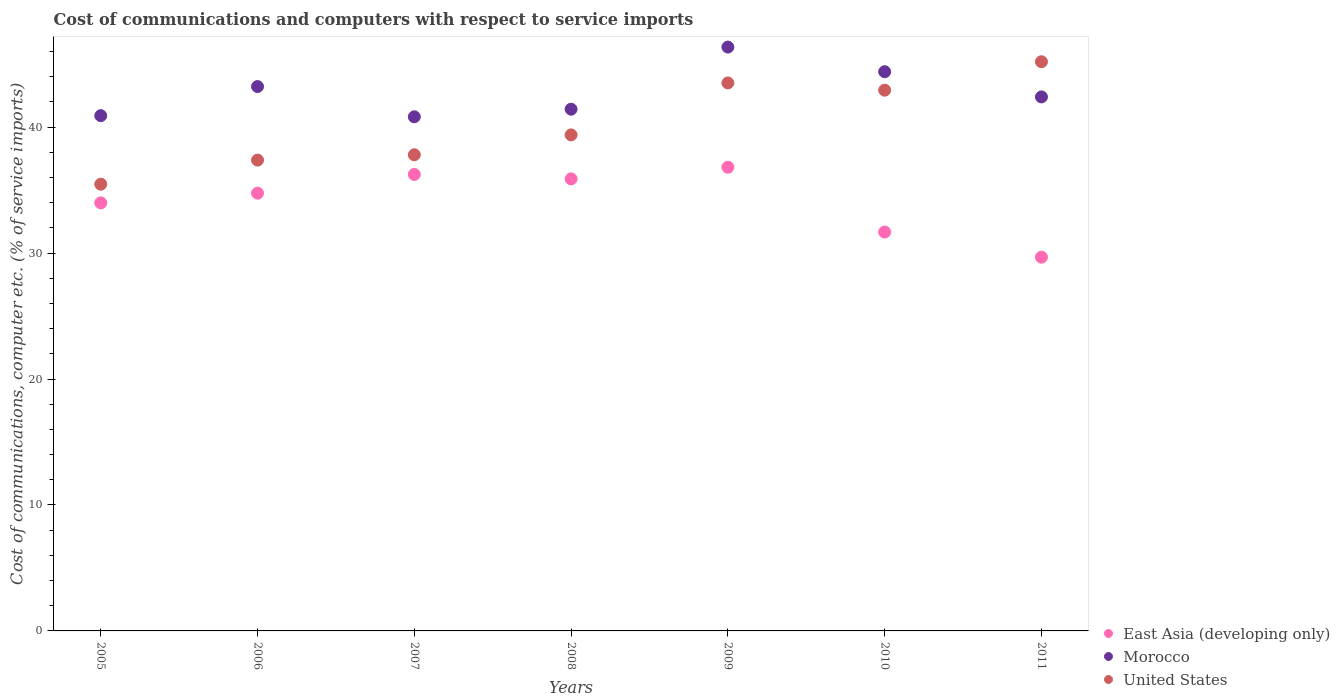Is the number of dotlines equal to the number of legend labels?
Provide a short and direct response. Yes. What is the cost of communications and computers in United States in 2010?
Offer a very short reply. 42.93. Across all years, what is the maximum cost of communications and computers in Morocco?
Offer a terse response. 46.36. Across all years, what is the minimum cost of communications and computers in Morocco?
Provide a succinct answer. 40.82. In which year was the cost of communications and computers in East Asia (developing only) maximum?
Keep it short and to the point. 2009. In which year was the cost of communications and computers in United States minimum?
Your response must be concise. 2005. What is the total cost of communications and computers in East Asia (developing only) in the graph?
Provide a succinct answer. 239.04. What is the difference between the cost of communications and computers in Morocco in 2006 and that in 2010?
Offer a very short reply. -1.18. What is the difference between the cost of communications and computers in East Asia (developing only) in 2011 and the cost of communications and computers in Morocco in 2008?
Your answer should be very brief. -11.75. What is the average cost of communications and computers in East Asia (developing only) per year?
Keep it short and to the point. 34.15. In the year 2011, what is the difference between the cost of communications and computers in Morocco and cost of communications and computers in United States?
Your answer should be compact. -2.79. In how many years, is the cost of communications and computers in United States greater than 16 %?
Ensure brevity in your answer.  7. What is the ratio of the cost of communications and computers in United States in 2010 to that in 2011?
Your response must be concise. 0.95. Is the cost of communications and computers in United States in 2007 less than that in 2008?
Ensure brevity in your answer.  Yes. Is the difference between the cost of communications and computers in Morocco in 2007 and 2011 greater than the difference between the cost of communications and computers in United States in 2007 and 2011?
Your answer should be very brief. Yes. What is the difference between the highest and the second highest cost of communications and computers in Morocco?
Provide a succinct answer. 1.95. What is the difference between the highest and the lowest cost of communications and computers in Morocco?
Your answer should be very brief. 5.54. Is the sum of the cost of communications and computers in United States in 2007 and 2009 greater than the maximum cost of communications and computers in East Asia (developing only) across all years?
Give a very brief answer. Yes. Is it the case that in every year, the sum of the cost of communications and computers in East Asia (developing only) and cost of communications and computers in United States  is greater than the cost of communications and computers in Morocco?
Keep it short and to the point. Yes. Does the cost of communications and computers in Morocco monotonically increase over the years?
Offer a very short reply. No. What is the difference between two consecutive major ticks on the Y-axis?
Your answer should be compact. 10. Are the values on the major ticks of Y-axis written in scientific E-notation?
Your answer should be compact. No. Does the graph contain any zero values?
Give a very brief answer. No. Where does the legend appear in the graph?
Your answer should be compact. Bottom right. How many legend labels are there?
Your response must be concise. 3. How are the legend labels stacked?
Provide a succinct answer. Vertical. What is the title of the graph?
Provide a succinct answer. Cost of communications and computers with respect to service imports. What is the label or title of the Y-axis?
Your answer should be very brief. Cost of communications, computer etc. (% of service imports). What is the Cost of communications, computer etc. (% of service imports) of East Asia (developing only) in 2005?
Give a very brief answer. 33.98. What is the Cost of communications, computer etc. (% of service imports) of Morocco in 2005?
Give a very brief answer. 40.91. What is the Cost of communications, computer etc. (% of service imports) in United States in 2005?
Offer a very short reply. 35.47. What is the Cost of communications, computer etc. (% of service imports) of East Asia (developing only) in 2006?
Your answer should be compact. 34.76. What is the Cost of communications, computer etc. (% of service imports) of Morocco in 2006?
Keep it short and to the point. 43.22. What is the Cost of communications, computer etc. (% of service imports) of United States in 2006?
Provide a short and direct response. 37.38. What is the Cost of communications, computer etc. (% of service imports) in East Asia (developing only) in 2007?
Give a very brief answer. 36.24. What is the Cost of communications, computer etc. (% of service imports) of Morocco in 2007?
Offer a very short reply. 40.82. What is the Cost of communications, computer etc. (% of service imports) in United States in 2007?
Offer a terse response. 37.8. What is the Cost of communications, computer etc. (% of service imports) in East Asia (developing only) in 2008?
Provide a short and direct response. 35.89. What is the Cost of communications, computer etc. (% of service imports) in Morocco in 2008?
Provide a succinct answer. 41.42. What is the Cost of communications, computer etc. (% of service imports) of United States in 2008?
Your answer should be compact. 39.38. What is the Cost of communications, computer etc. (% of service imports) in East Asia (developing only) in 2009?
Your answer should be very brief. 36.82. What is the Cost of communications, computer etc. (% of service imports) of Morocco in 2009?
Provide a succinct answer. 46.36. What is the Cost of communications, computer etc. (% of service imports) of United States in 2009?
Provide a short and direct response. 43.51. What is the Cost of communications, computer etc. (% of service imports) of East Asia (developing only) in 2010?
Your response must be concise. 31.67. What is the Cost of communications, computer etc. (% of service imports) of Morocco in 2010?
Give a very brief answer. 44.4. What is the Cost of communications, computer etc. (% of service imports) in United States in 2010?
Provide a succinct answer. 42.93. What is the Cost of communications, computer etc. (% of service imports) of East Asia (developing only) in 2011?
Offer a very short reply. 29.67. What is the Cost of communications, computer etc. (% of service imports) of Morocco in 2011?
Provide a short and direct response. 42.4. What is the Cost of communications, computer etc. (% of service imports) of United States in 2011?
Keep it short and to the point. 45.19. Across all years, what is the maximum Cost of communications, computer etc. (% of service imports) in East Asia (developing only)?
Offer a terse response. 36.82. Across all years, what is the maximum Cost of communications, computer etc. (% of service imports) in Morocco?
Your answer should be compact. 46.36. Across all years, what is the maximum Cost of communications, computer etc. (% of service imports) of United States?
Provide a succinct answer. 45.19. Across all years, what is the minimum Cost of communications, computer etc. (% of service imports) of East Asia (developing only)?
Your response must be concise. 29.67. Across all years, what is the minimum Cost of communications, computer etc. (% of service imports) of Morocco?
Provide a succinct answer. 40.82. Across all years, what is the minimum Cost of communications, computer etc. (% of service imports) of United States?
Your response must be concise. 35.47. What is the total Cost of communications, computer etc. (% of service imports) of East Asia (developing only) in the graph?
Keep it short and to the point. 239.04. What is the total Cost of communications, computer etc. (% of service imports) in Morocco in the graph?
Make the answer very short. 299.53. What is the total Cost of communications, computer etc. (% of service imports) of United States in the graph?
Your answer should be very brief. 281.67. What is the difference between the Cost of communications, computer etc. (% of service imports) of East Asia (developing only) in 2005 and that in 2006?
Your answer should be very brief. -0.77. What is the difference between the Cost of communications, computer etc. (% of service imports) in Morocco in 2005 and that in 2006?
Make the answer very short. -2.31. What is the difference between the Cost of communications, computer etc. (% of service imports) in United States in 2005 and that in 2006?
Your answer should be compact. -1.91. What is the difference between the Cost of communications, computer etc. (% of service imports) in East Asia (developing only) in 2005 and that in 2007?
Provide a succinct answer. -2.26. What is the difference between the Cost of communications, computer etc. (% of service imports) in Morocco in 2005 and that in 2007?
Provide a succinct answer. 0.09. What is the difference between the Cost of communications, computer etc. (% of service imports) of United States in 2005 and that in 2007?
Provide a succinct answer. -2.34. What is the difference between the Cost of communications, computer etc. (% of service imports) of East Asia (developing only) in 2005 and that in 2008?
Your answer should be compact. -1.91. What is the difference between the Cost of communications, computer etc. (% of service imports) of Morocco in 2005 and that in 2008?
Ensure brevity in your answer.  -0.51. What is the difference between the Cost of communications, computer etc. (% of service imports) in United States in 2005 and that in 2008?
Offer a very short reply. -3.92. What is the difference between the Cost of communications, computer etc. (% of service imports) of East Asia (developing only) in 2005 and that in 2009?
Make the answer very short. -2.83. What is the difference between the Cost of communications, computer etc. (% of service imports) in Morocco in 2005 and that in 2009?
Keep it short and to the point. -5.44. What is the difference between the Cost of communications, computer etc. (% of service imports) in United States in 2005 and that in 2009?
Provide a short and direct response. -8.04. What is the difference between the Cost of communications, computer etc. (% of service imports) in East Asia (developing only) in 2005 and that in 2010?
Your answer should be very brief. 2.32. What is the difference between the Cost of communications, computer etc. (% of service imports) in Morocco in 2005 and that in 2010?
Offer a very short reply. -3.49. What is the difference between the Cost of communications, computer etc. (% of service imports) of United States in 2005 and that in 2010?
Offer a terse response. -7.47. What is the difference between the Cost of communications, computer etc. (% of service imports) of East Asia (developing only) in 2005 and that in 2011?
Offer a terse response. 4.31. What is the difference between the Cost of communications, computer etc. (% of service imports) in Morocco in 2005 and that in 2011?
Provide a short and direct response. -1.49. What is the difference between the Cost of communications, computer etc. (% of service imports) in United States in 2005 and that in 2011?
Your answer should be very brief. -9.72. What is the difference between the Cost of communications, computer etc. (% of service imports) of East Asia (developing only) in 2006 and that in 2007?
Offer a very short reply. -1.49. What is the difference between the Cost of communications, computer etc. (% of service imports) in Morocco in 2006 and that in 2007?
Offer a terse response. 2.4. What is the difference between the Cost of communications, computer etc. (% of service imports) in United States in 2006 and that in 2007?
Offer a terse response. -0.42. What is the difference between the Cost of communications, computer etc. (% of service imports) in East Asia (developing only) in 2006 and that in 2008?
Your response must be concise. -1.14. What is the difference between the Cost of communications, computer etc. (% of service imports) in Morocco in 2006 and that in 2008?
Your answer should be very brief. 1.8. What is the difference between the Cost of communications, computer etc. (% of service imports) in United States in 2006 and that in 2008?
Keep it short and to the point. -2. What is the difference between the Cost of communications, computer etc. (% of service imports) of East Asia (developing only) in 2006 and that in 2009?
Your answer should be compact. -2.06. What is the difference between the Cost of communications, computer etc. (% of service imports) in Morocco in 2006 and that in 2009?
Keep it short and to the point. -3.14. What is the difference between the Cost of communications, computer etc. (% of service imports) of United States in 2006 and that in 2009?
Ensure brevity in your answer.  -6.13. What is the difference between the Cost of communications, computer etc. (% of service imports) of East Asia (developing only) in 2006 and that in 2010?
Your answer should be compact. 3.09. What is the difference between the Cost of communications, computer etc. (% of service imports) in Morocco in 2006 and that in 2010?
Offer a very short reply. -1.18. What is the difference between the Cost of communications, computer etc. (% of service imports) in United States in 2006 and that in 2010?
Make the answer very short. -5.55. What is the difference between the Cost of communications, computer etc. (% of service imports) in East Asia (developing only) in 2006 and that in 2011?
Make the answer very short. 5.08. What is the difference between the Cost of communications, computer etc. (% of service imports) in Morocco in 2006 and that in 2011?
Provide a short and direct response. 0.82. What is the difference between the Cost of communications, computer etc. (% of service imports) of United States in 2006 and that in 2011?
Offer a very short reply. -7.81. What is the difference between the Cost of communications, computer etc. (% of service imports) of East Asia (developing only) in 2007 and that in 2008?
Your answer should be compact. 0.35. What is the difference between the Cost of communications, computer etc. (% of service imports) of Morocco in 2007 and that in 2008?
Offer a terse response. -0.6. What is the difference between the Cost of communications, computer etc. (% of service imports) in United States in 2007 and that in 2008?
Make the answer very short. -1.58. What is the difference between the Cost of communications, computer etc. (% of service imports) of East Asia (developing only) in 2007 and that in 2009?
Your response must be concise. -0.57. What is the difference between the Cost of communications, computer etc. (% of service imports) in Morocco in 2007 and that in 2009?
Keep it short and to the point. -5.54. What is the difference between the Cost of communications, computer etc. (% of service imports) in United States in 2007 and that in 2009?
Your answer should be compact. -5.7. What is the difference between the Cost of communications, computer etc. (% of service imports) in East Asia (developing only) in 2007 and that in 2010?
Ensure brevity in your answer.  4.58. What is the difference between the Cost of communications, computer etc. (% of service imports) in Morocco in 2007 and that in 2010?
Your response must be concise. -3.58. What is the difference between the Cost of communications, computer etc. (% of service imports) in United States in 2007 and that in 2010?
Provide a short and direct response. -5.13. What is the difference between the Cost of communications, computer etc. (% of service imports) of East Asia (developing only) in 2007 and that in 2011?
Give a very brief answer. 6.57. What is the difference between the Cost of communications, computer etc. (% of service imports) in Morocco in 2007 and that in 2011?
Provide a succinct answer. -1.58. What is the difference between the Cost of communications, computer etc. (% of service imports) in United States in 2007 and that in 2011?
Offer a very short reply. -7.39. What is the difference between the Cost of communications, computer etc. (% of service imports) in East Asia (developing only) in 2008 and that in 2009?
Give a very brief answer. -0.93. What is the difference between the Cost of communications, computer etc. (% of service imports) of Morocco in 2008 and that in 2009?
Your answer should be compact. -4.93. What is the difference between the Cost of communications, computer etc. (% of service imports) of United States in 2008 and that in 2009?
Give a very brief answer. -4.12. What is the difference between the Cost of communications, computer etc. (% of service imports) in East Asia (developing only) in 2008 and that in 2010?
Provide a succinct answer. 4.22. What is the difference between the Cost of communications, computer etc. (% of service imports) of Morocco in 2008 and that in 2010?
Offer a terse response. -2.98. What is the difference between the Cost of communications, computer etc. (% of service imports) of United States in 2008 and that in 2010?
Your response must be concise. -3.55. What is the difference between the Cost of communications, computer etc. (% of service imports) of East Asia (developing only) in 2008 and that in 2011?
Ensure brevity in your answer.  6.22. What is the difference between the Cost of communications, computer etc. (% of service imports) in Morocco in 2008 and that in 2011?
Your answer should be very brief. -0.98. What is the difference between the Cost of communications, computer etc. (% of service imports) in United States in 2008 and that in 2011?
Offer a very short reply. -5.81. What is the difference between the Cost of communications, computer etc. (% of service imports) in East Asia (developing only) in 2009 and that in 2010?
Make the answer very short. 5.15. What is the difference between the Cost of communications, computer etc. (% of service imports) in Morocco in 2009 and that in 2010?
Your answer should be compact. 1.95. What is the difference between the Cost of communications, computer etc. (% of service imports) in United States in 2009 and that in 2010?
Give a very brief answer. 0.57. What is the difference between the Cost of communications, computer etc. (% of service imports) of East Asia (developing only) in 2009 and that in 2011?
Give a very brief answer. 7.14. What is the difference between the Cost of communications, computer etc. (% of service imports) in Morocco in 2009 and that in 2011?
Offer a very short reply. 3.96. What is the difference between the Cost of communications, computer etc. (% of service imports) in United States in 2009 and that in 2011?
Offer a terse response. -1.68. What is the difference between the Cost of communications, computer etc. (% of service imports) in East Asia (developing only) in 2010 and that in 2011?
Keep it short and to the point. 1.99. What is the difference between the Cost of communications, computer etc. (% of service imports) in Morocco in 2010 and that in 2011?
Make the answer very short. 2. What is the difference between the Cost of communications, computer etc. (% of service imports) in United States in 2010 and that in 2011?
Offer a very short reply. -2.26. What is the difference between the Cost of communications, computer etc. (% of service imports) of East Asia (developing only) in 2005 and the Cost of communications, computer etc. (% of service imports) of Morocco in 2006?
Make the answer very short. -9.24. What is the difference between the Cost of communications, computer etc. (% of service imports) of East Asia (developing only) in 2005 and the Cost of communications, computer etc. (% of service imports) of United States in 2006?
Ensure brevity in your answer.  -3.4. What is the difference between the Cost of communications, computer etc. (% of service imports) in Morocco in 2005 and the Cost of communications, computer etc. (% of service imports) in United States in 2006?
Make the answer very short. 3.53. What is the difference between the Cost of communications, computer etc. (% of service imports) in East Asia (developing only) in 2005 and the Cost of communications, computer etc. (% of service imports) in Morocco in 2007?
Provide a short and direct response. -6.84. What is the difference between the Cost of communications, computer etc. (% of service imports) of East Asia (developing only) in 2005 and the Cost of communications, computer etc. (% of service imports) of United States in 2007?
Offer a very short reply. -3.82. What is the difference between the Cost of communications, computer etc. (% of service imports) of Morocco in 2005 and the Cost of communications, computer etc. (% of service imports) of United States in 2007?
Keep it short and to the point. 3.11. What is the difference between the Cost of communications, computer etc. (% of service imports) of East Asia (developing only) in 2005 and the Cost of communications, computer etc. (% of service imports) of Morocco in 2008?
Keep it short and to the point. -7.44. What is the difference between the Cost of communications, computer etc. (% of service imports) in East Asia (developing only) in 2005 and the Cost of communications, computer etc. (% of service imports) in United States in 2008?
Offer a very short reply. -5.4. What is the difference between the Cost of communications, computer etc. (% of service imports) in Morocco in 2005 and the Cost of communications, computer etc. (% of service imports) in United States in 2008?
Provide a short and direct response. 1.53. What is the difference between the Cost of communications, computer etc. (% of service imports) of East Asia (developing only) in 2005 and the Cost of communications, computer etc. (% of service imports) of Morocco in 2009?
Give a very brief answer. -12.37. What is the difference between the Cost of communications, computer etc. (% of service imports) in East Asia (developing only) in 2005 and the Cost of communications, computer etc. (% of service imports) in United States in 2009?
Your answer should be very brief. -9.52. What is the difference between the Cost of communications, computer etc. (% of service imports) in Morocco in 2005 and the Cost of communications, computer etc. (% of service imports) in United States in 2009?
Your response must be concise. -2.6. What is the difference between the Cost of communications, computer etc. (% of service imports) in East Asia (developing only) in 2005 and the Cost of communications, computer etc. (% of service imports) in Morocco in 2010?
Keep it short and to the point. -10.42. What is the difference between the Cost of communications, computer etc. (% of service imports) of East Asia (developing only) in 2005 and the Cost of communications, computer etc. (% of service imports) of United States in 2010?
Give a very brief answer. -8.95. What is the difference between the Cost of communications, computer etc. (% of service imports) of Morocco in 2005 and the Cost of communications, computer etc. (% of service imports) of United States in 2010?
Your answer should be very brief. -2.02. What is the difference between the Cost of communications, computer etc. (% of service imports) in East Asia (developing only) in 2005 and the Cost of communications, computer etc. (% of service imports) in Morocco in 2011?
Make the answer very short. -8.42. What is the difference between the Cost of communications, computer etc. (% of service imports) of East Asia (developing only) in 2005 and the Cost of communications, computer etc. (% of service imports) of United States in 2011?
Offer a terse response. -11.21. What is the difference between the Cost of communications, computer etc. (% of service imports) in Morocco in 2005 and the Cost of communications, computer etc. (% of service imports) in United States in 2011?
Your answer should be compact. -4.28. What is the difference between the Cost of communications, computer etc. (% of service imports) of East Asia (developing only) in 2006 and the Cost of communications, computer etc. (% of service imports) of Morocco in 2007?
Ensure brevity in your answer.  -6.06. What is the difference between the Cost of communications, computer etc. (% of service imports) in East Asia (developing only) in 2006 and the Cost of communications, computer etc. (% of service imports) in United States in 2007?
Ensure brevity in your answer.  -3.05. What is the difference between the Cost of communications, computer etc. (% of service imports) in Morocco in 2006 and the Cost of communications, computer etc. (% of service imports) in United States in 2007?
Your answer should be compact. 5.42. What is the difference between the Cost of communications, computer etc. (% of service imports) of East Asia (developing only) in 2006 and the Cost of communications, computer etc. (% of service imports) of Morocco in 2008?
Your response must be concise. -6.67. What is the difference between the Cost of communications, computer etc. (% of service imports) of East Asia (developing only) in 2006 and the Cost of communications, computer etc. (% of service imports) of United States in 2008?
Provide a short and direct response. -4.63. What is the difference between the Cost of communications, computer etc. (% of service imports) in Morocco in 2006 and the Cost of communications, computer etc. (% of service imports) in United States in 2008?
Keep it short and to the point. 3.84. What is the difference between the Cost of communications, computer etc. (% of service imports) in East Asia (developing only) in 2006 and the Cost of communications, computer etc. (% of service imports) in Morocco in 2009?
Offer a very short reply. -11.6. What is the difference between the Cost of communications, computer etc. (% of service imports) of East Asia (developing only) in 2006 and the Cost of communications, computer etc. (% of service imports) of United States in 2009?
Make the answer very short. -8.75. What is the difference between the Cost of communications, computer etc. (% of service imports) of Morocco in 2006 and the Cost of communications, computer etc. (% of service imports) of United States in 2009?
Offer a very short reply. -0.29. What is the difference between the Cost of communications, computer etc. (% of service imports) of East Asia (developing only) in 2006 and the Cost of communications, computer etc. (% of service imports) of Morocco in 2010?
Your answer should be compact. -9.65. What is the difference between the Cost of communications, computer etc. (% of service imports) in East Asia (developing only) in 2006 and the Cost of communications, computer etc. (% of service imports) in United States in 2010?
Provide a short and direct response. -8.18. What is the difference between the Cost of communications, computer etc. (% of service imports) of Morocco in 2006 and the Cost of communications, computer etc. (% of service imports) of United States in 2010?
Your answer should be very brief. 0.29. What is the difference between the Cost of communications, computer etc. (% of service imports) of East Asia (developing only) in 2006 and the Cost of communications, computer etc. (% of service imports) of Morocco in 2011?
Your response must be concise. -7.65. What is the difference between the Cost of communications, computer etc. (% of service imports) in East Asia (developing only) in 2006 and the Cost of communications, computer etc. (% of service imports) in United States in 2011?
Offer a very short reply. -10.44. What is the difference between the Cost of communications, computer etc. (% of service imports) of Morocco in 2006 and the Cost of communications, computer etc. (% of service imports) of United States in 2011?
Your answer should be very brief. -1.97. What is the difference between the Cost of communications, computer etc. (% of service imports) in East Asia (developing only) in 2007 and the Cost of communications, computer etc. (% of service imports) in Morocco in 2008?
Your answer should be very brief. -5.18. What is the difference between the Cost of communications, computer etc. (% of service imports) in East Asia (developing only) in 2007 and the Cost of communications, computer etc. (% of service imports) in United States in 2008?
Your answer should be compact. -3.14. What is the difference between the Cost of communications, computer etc. (% of service imports) in Morocco in 2007 and the Cost of communications, computer etc. (% of service imports) in United States in 2008?
Offer a terse response. 1.44. What is the difference between the Cost of communications, computer etc. (% of service imports) of East Asia (developing only) in 2007 and the Cost of communications, computer etc. (% of service imports) of Morocco in 2009?
Give a very brief answer. -10.11. What is the difference between the Cost of communications, computer etc. (% of service imports) of East Asia (developing only) in 2007 and the Cost of communications, computer etc. (% of service imports) of United States in 2009?
Your answer should be very brief. -7.26. What is the difference between the Cost of communications, computer etc. (% of service imports) in Morocco in 2007 and the Cost of communications, computer etc. (% of service imports) in United States in 2009?
Provide a succinct answer. -2.69. What is the difference between the Cost of communications, computer etc. (% of service imports) in East Asia (developing only) in 2007 and the Cost of communications, computer etc. (% of service imports) in Morocco in 2010?
Provide a short and direct response. -8.16. What is the difference between the Cost of communications, computer etc. (% of service imports) of East Asia (developing only) in 2007 and the Cost of communications, computer etc. (% of service imports) of United States in 2010?
Provide a succinct answer. -6.69. What is the difference between the Cost of communications, computer etc. (% of service imports) in Morocco in 2007 and the Cost of communications, computer etc. (% of service imports) in United States in 2010?
Make the answer very short. -2.11. What is the difference between the Cost of communications, computer etc. (% of service imports) in East Asia (developing only) in 2007 and the Cost of communications, computer etc. (% of service imports) in Morocco in 2011?
Give a very brief answer. -6.16. What is the difference between the Cost of communications, computer etc. (% of service imports) of East Asia (developing only) in 2007 and the Cost of communications, computer etc. (% of service imports) of United States in 2011?
Your answer should be very brief. -8.95. What is the difference between the Cost of communications, computer etc. (% of service imports) in Morocco in 2007 and the Cost of communications, computer etc. (% of service imports) in United States in 2011?
Keep it short and to the point. -4.37. What is the difference between the Cost of communications, computer etc. (% of service imports) of East Asia (developing only) in 2008 and the Cost of communications, computer etc. (% of service imports) of Morocco in 2009?
Make the answer very short. -10.47. What is the difference between the Cost of communications, computer etc. (% of service imports) of East Asia (developing only) in 2008 and the Cost of communications, computer etc. (% of service imports) of United States in 2009?
Offer a terse response. -7.62. What is the difference between the Cost of communications, computer etc. (% of service imports) of Morocco in 2008 and the Cost of communications, computer etc. (% of service imports) of United States in 2009?
Provide a short and direct response. -2.08. What is the difference between the Cost of communications, computer etc. (% of service imports) of East Asia (developing only) in 2008 and the Cost of communications, computer etc. (% of service imports) of Morocco in 2010?
Make the answer very short. -8.51. What is the difference between the Cost of communications, computer etc. (% of service imports) of East Asia (developing only) in 2008 and the Cost of communications, computer etc. (% of service imports) of United States in 2010?
Give a very brief answer. -7.04. What is the difference between the Cost of communications, computer etc. (% of service imports) of Morocco in 2008 and the Cost of communications, computer etc. (% of service imports) of United States in 2010?
Your answer should be compact. -1.51. What is the difference between the Cost of communications, computer etc. (% of service imports) in East Asia (developing only) in 2008 and the Cost of communications, computer etc. (% of service imports) in Morocco in 2011?
Offer a very short reply. -6.51. What is the difference between the Cost of communications, computer etc. (% of service imports) in East Asia (developing only) in 2008 and the Cost of communications, computer etc. (% of service imports) in United States in 2011?
Offer a terse response. -9.3. What is the difference between the Cost of communications, computer etc. (% of service imports) of Morocco in 2008 and the Cost of communications, computer etc. (% of service imports) of United States in 2011?
Give a very brief answer. -3.77. What is the difference between the Cost of communications, computer etc. (% of service imports) of East Asia (developing only) in 2009 and the Cost of communications, computer etc. (% of service imports) of Morocco in 2010?
Offer a very short reply. -7.58. What is the difference between the Cost of communications, computer etc. (% of service imports) in East Asia (developing only) in 2009 and the Cost of communications, computer etc. (% of service imports) in United States in 2010?
Make the answer very short. -6.12. What is the difference between the Cost of communications, computer etc. (% of service imports) of Morocco in 2009 and the Cost of communications, computer etc. (% of service imports) of United States in 2010?
Provide a succinct answer. 3.42. What is the difference between the Cost of communications, computer etc. (% of service imports) in East Asia (developing only) in 2009 and the Cost of communications, computer etc. (% of service imports) in Morocco in 2011?
Ensure brevity in your answer.  -5.58. What is the difference between the Cost of communications, computer etc. (% of service imports) in East Asia (developing only) in 2009 and the Cost of communications, computer etc. (% of service imports) in United States in 2011?
Offer a terse response. -8.37. What is the difference between the Cost of communications, computer etc. (% of service imports) in Morocco in 2009 and the Cost of communications, computer etc. (% of service imports) in United States in 2011?
Provide a succinct answer. 1.16. What is the difference between the Cost of communications, computer etc. (% of service imports) in East Asia (developing only) in 2010 and the Cost of communications, computer etc. (% of service imports) in Morocco in 2011?
Keep it short and to the point. -10.73. What is the difference between the Cost of communications, computer etc. (% of service imports) of East Asia (developing only) in 2010 and the Cost of communications, computer etc. (% of service imports) of United States in 2011?
Make the answer very short. -13.52. What is the difference between the Cost of communications, computer etc. (% of service imports) in Morocco in 2010 and the Cost of communications, computer etc. (% of service imports) in United States in 2011?
Your answer should be compact. -0.79. What is the average Cost of communications, computer etc. (% of service imports) in East Asia (developing only) per year?
Your answer should be very brief. 34.15. What is the average Cost of communications, computer etc. (% of service imports) of Morocco per year?
Keep it short and to the point. 42.79. What is the average Cost of communications, computer etc. (% of service imports) in United States per year?
Make the answer very short. 40.24. In the year 2005, what is the difference between the Cost of communications, computer etc. (% of service imports) of East Asia (developing only) and Cost of communications, computer etc. (% of service imports) of Morocco?
Provide a short and direct response. -6.93. In the year 2005, what is the difference between the Cost of communications, computer etc. (% of service imports) in East Asia (developing only) and Cost of communications, computer etc. (% of service imports) in United States?
Your response must be concise. -1.48. In the year 2005, what is the difference between the Cost of communications, computer etc. (% of service imports) of Morocco and Cost of communications, computer etc. (% of service imports) of United States?
Make the answer very short. 5.44. In the year 2006, what is the difference between the Cost of communications, computer etc. (% of service imports) of East Asia (developing only) and Cost of communications, computer etc. (% of service imports) of Morocco?
Make the answer very short. -8.47. In the year 2006, what is the difference between the Cost of communications, computer etc. (% of service imports) in East Asia (developing only) and Cost of communications, computer etc. (% of service imports) in United States?
Offer a very short reply. -2.63. In the year 2006, what is the difference between the Cost of communications, computer etc. (% of service imports) of Morocco and Cost of communications, computer etc. (% of service imports) of United States?
Your answer should be compact. 5.84. In the year 2007, what is the difference between the Cost of communications, computer etc. (% of service imports) in East Asia (developing only) and Cost of communications, computer etc. (% of service imports) in Morocco?
Your answer should be compact. -4.57. In the year 2007, what is the difference between the Cost of communications, computer etc. (% of service imports) in East Asia (developing only) and Cost of communications, computer etc. (% of service imports) in United States?
Your response must be concise. -1.56. In the year 2007, what is the difference between the Cost of communications, computer etc. (% of service imports) in Morocco and Cost of communications, computer etc. (% of service imports) in United States?
Offer a very short reply. 3.02. In the year 2008, what is the difference between the Cost of communications, computer etc. (% of service imports) of East Asia (developing only) and Cost of communications, computer etc. (% of service imports) of Morocco?
Give a very brief answer. -5.53. In the year 2008, what is the difference between the Cost of communications, computer etc. (% of service imports) of East Asia (developing only) and Cost of communications, computer etc. (% of service imports) of United States?
Your answer should be very brief. -3.49. In the year 2008, what is the difference between the Cost of communications, computer etc. (% of service imports) of Morocco and Cost of communications, computer etc. (% of service imports) of United States?
Your response must be concise. 2.04. In the year 2009, what is the difference between the Cost of communications, computer etc. (% of service imports) in East Asia (developing only) and Cost of communications, computer etc. (% of service imports) in Morocco?
Offer a terse response. -9.54. In the year 2009, what is the difference between the Cost of communications, computer etc. (% of service imports) in East Asia (developing only) and Cost of communications, computer etc. (% of service imports) in United States?
Provide a short and direct response. -6.69. In the year 2009, what is the difference between the Cost of communications, computer etc. (% of service imports) of Morocco and Cost of communications, computer etc. (% of service imports) of United States?
Keep it short and to the point. 2.85. In the year 2010, what is the difference between the Cost of communications, computer etc. (% of service imports) of East Asia (developing only) and Cost of communications, computer etc. (% of service imports) of Morocco?
Keep it short and to the point. -12.73. In the year 2010, what is the difference between the Cost of communications, computer etc. (% of service imports) of East Asia (developing only) and Cost of communications, computer etc. (% of service imports) of United States?
Offer a terse response. -11.26. In the year 2010, what is the difference between the Cost of communications, computer etc. (% of service imports) of Morocco and Cost of communications, computer etc. (% of service imports) of United States?
Offer a very short reply. 1.47. In the year 2011, what is the difference between the Cost of communications, computer etc. (% of service imports) of East Asia (developing only) and Cost of communications, computer etc. (% of service imports) of Morocco?
Your answer should be very brief. -12.73. In the year 2011, what is the difference between the Cost of communications, computer etc. (% of service imports) of East Asia (developing only) and Cost of communications, computer etc. (% of service imports) of United States?
Your response must be concise. -15.52. In the year 2011, what is the difference between the Cost of communications, computer etc. (% of service imports) of Morocco and Cost of communications, computer etc. (% of service imports) of United States?
Offer a terse response. -2.79. What is the ratio of the Cost of communications, computer etc. (% of service imports) in East Asia (developing only) in 2005 to that in 2006?
Make the answer very short. 0.98. What is the ratio of the Cost of communications, computer etc. (% of service imports) in Morocco in 2005 to that in 2006?
Give a very brief answer. 0.95. What is the ratio of the Cost of communications, computer etc. (% of service imports) of United States in 2005 to that in 2006?
Give a very brief answer. 0.95. What is the ratio of the Cost of communications, computer etc. (% of service imports) of East Asia (developing only) in 2005 to that in 2007?
Your answer should be very brief. 0.94. What is the ratio of the Cost of communications, computer etc. (% of service imports) in Morocco in 2005 to that in 2007?
Make the answer very short. 1. What is the ratio of the Cost of communications, computer etc. (% of service imports) of United States in 2005 to that in 2007?
Keep it short and to the point. 0.94. What is the ratio of the Cost of communications, computer etc. (% of service imports) of East Asia (developing only) in 2005 to that in 2008?
Provide a short and direct response. 0.95. What is the ratio of the Cost of communications, computer etc. (% of service imports) of Morocco in 2005 to that in 2008?
Offer a very short reply. 0.99. What is the ratio of the Cost of communications, computer etc. (% of service imports) of United States in 2005 to that in 2008?
Your response must be concise. 0.9. What is the ratio of the Cost of communications, computer etc. (% of service imports) of East Asia (developing only) in 2005 to that in 2009?
Your answer should be compact. 0.92. What is the ratio of the Cost of communications, computer etc. (% of service imports) in Morocco in 2005 to that in 2009?
Your response must be concise. 0.88. What is the ratio of the Cost of communications, computer etc. (% of service imports) of United States in 2005 to that in 2009?
Your response must be concise. 0.82. What is the ratio of the Cost of communications, computer etc. (% of service imports) of East Asia (developing only) in 2005 to that in 2010?
Offer a very short reply. 1.07. What is the ratio of the Cost of communications, computer etc. (% of service imports) of Morocco in 2005 to that in 2010?
Your answer should be very brief. 0.92. What is the ratio of the Cost of communications, computer etc. (% of service imports) of United States in 2005 to that in 2010?
Offer a terse response. 0.83. What is the ratio of the Cost of communications, computer etc. (% of service imports) of East Asia (developing only) in 2005 to that in 2011?
Your response must be concise. 1.15. What is the ratio of the Cost of communications, computer etc. (% of service imports) in Morocco in 2005 to that in 2011?
Your answer should be very brief. 0.96. What is the ratio of the Cost of communications, computer etc. (% of service imports) in United States in 2005 to that in 2011?
Provide a short and direct response. 0.78. What is the ratio of the Cost of communications, computer etc. (% of service imports) in East Asia (developing only) in 2006 to that in 2007?
Offer a terse response. 0.96. What is the ratio of the Cost of communications, computer etc. (% of service imports) in Morocco in 2006 to that in 2007?
Offer a very short reply. 1.06. What is the ratio of the Cost of communications, computer etc. (% of service imports) of East Asia (developing only) in 2006 to that in 2008?
Your answer should be compact. 0.97. What is the ratio of the Cost of communications, computer etc. (% of service imports) in Morocco in 2006 to that in 2008?
Keep it short and to the point. 1.04. What is the ratio of the Cost of communications, computer etc. (% of service imports) of United States in 2006 to that in 2008?
Give a very brief answer. 0.95. What is the ratio of the Cost of communications, computer etc. (% of service imports) in East Asia (developing only) in 2006 to that in 2009?
Offer a very short reply. 0.94. What is the ratio of the Cost of communications, computer etc. (% of service imports) in Morocco in 2006 to that in 2009?
Offer a very short reply. 0.93. What is the ratio of the Cost of communications, computer etc. (% of service imports) in United States in 2006 to that in 2009?
Ensure brevity in your answer.  0.86. What is the ratio of the Cost of communications, computer etc. (% of service imports) of East Asia (developing only) in 2006 to that in 2010?
Your answer should be very brief. 1.1. What is the ratio of the Cost of communications, computer etc. (% of service imports) in Morocco in 2006 to that in 2010?
Provide a succinct answer. 0.97. What is the ratio of the Cost of communications, computer etc. (% of service imports) of United States in 2006 to that in 2010?
Keep it short and to the point. 0.87. What is the ratio of the Cost of communications, computer etc. (% of service imports) of East Asia (developing only) in 2006 to that in 2011?
Your answer should be very brief. 1.17. What is the ratio of the Cost of communications, computer etc. (% of service imports) of Morocco in 2006 to that in 2011?
Provide a succinct answer. 1.02. What is the ratio of the Cost of communications, computer etc. (% of service imports) of United States in 2006 to that in 2011?
Give a very brief answer. 0.83. What is the ratio of the Cost of communications, computer etc. (% of service imports) in East Asia (developing only) in 2007 to that in 2008?
Offer a terse response. 1.01. What is the ratio of the Cost of communications, computer etc. (% of service imports) in Morocco in 2007 to that in 2008?
Your response must be concise. 0.99. What is the ratio of the Cost of communications, computer etc. (% of service imports) of United States in 2007 to that in 2008?
Provide a succinct answer. 0.96. What is the ratio of the Cost of communications, computer etc. (% of service imports) in East Asia (developing only) in 2007 to that in 2009?
Your response must be concise. 0.98. What is the ratio of the Cost of communications, computer etc. (% of service imports) of Morocco in 2007 to that in 2009?
Provide a short and direct response. 0.88. What is the ratio of the Cost of communications, computer etc. (% of service imports) in United States in 2007 to that in 2009?
Keep it short and to the point. 0.87. What is the ratio of the Cost of communications, computer etc. (% of service imports) in East Asia (developing only) in 2007 to that in 2010?
Make the answer very short. 1.14. What is the ratio of the Cost of communications, computer etc. (% of service imports) in Morocco in 2007 to that in 2010?
Make the answer very short. 0.92. What is the ratio of the Cost of communications, computer etc. (% of service imports) in United States in 2007 to that in 2010?
Keep it short and to the point. 0.88. What is the ratio of the Cost of communications, computer etc. (% of service imports) in East Asia (developing only) in 2007 to that in 2011?
Make the answer very short. 1.22. What is the ratio of the Cost of communications, computer etc. (% of service imports) of Morocco in 2007 to that in 2011?
Your answer should be compact. 0.96. What is the ratio of the Cost of communications, computer etc. (% of service imports) in United States in 2007 to that in 2011?
Provide a short and direct response. 0.84. What is the ratio of the Cost of communications, computer etc. (% of service imports) of East Asia (developing only) in 2008 to that in 2009?
Your response must be concise. 0.97. What is the ratio of the Cost of communications, computer etc. (% of service imports) in Morocco in 2008 to that in 2009?
Provide a short and direct response. 0.89. What is the ratio of the Cost of communications, computer etc. (% of service imports) of United States in 2008 to that in 2009?
Provide a succinct answer. 0.91. What is the ratio of the Cost of communications, computer etc. (% of service imports) in East Asia (developing only) in 2008 to that in 2010?
Keep it short and to the point. 1.13. What is the ratio of the Cost of communications, computer etc. (% of service imports) of Morocco in 2008 to that in 2010?
Ensure brevity in your answer.  0.93. What is the ratio of the Cost of communications, computer etc. (% of service imports) in United States in 2008 to that in 2010?
Offer a very short reply. 0.92. What is the ratio of the Cost of communications, computer etc. (% of service imports) in East Asia (developing only) in 2008 to that in 2011?
Your answer should be very brief. 1.21. What is the ratio of the Cost of communications, computer etc. (% of service imports) of United States in 2008 to that in 2011?
Give a very brief answer. 0.87. What is the ratio of the Cost of communications, computer etc. (% of service imports) in East Asia (developing only) in 2009 to that in 2010?
Provide a short and direct response. 1.16. What is the ratio of the Cost of communications, computer etc. (% of service imports) in Morocco in 2009 to that in 2010?
Ensure brevity in your answer.  1.04. What is the ratio of the Cost of communications, computer etc. (% of service imports) of United States in 2009 to that in 2010?
Offer a terse response. 1.01. What is the ratio of the Cost of communications, computer etc. (% of service imports) in East Asia (developing only) in 2009 to that in 2011?
Make the answer very short. 1.24. What is the ratio of the Cost of communications, computer etc. (% of service imports) of Morocco in 2009 to that in 2011?
Provide a succinct answer. 1.09. What is the ratio of the Cost of communications, computer etc. (% of service imports) of United States in 2009 to that in 2011?
Offer a terse response. 0.96. What is the ratio of the Cost of communications, computer etc. (% of service imports) in East Asia (developing only) in 2010 to that in 2011?
Your answer should be very brief. 1.07. What is the ratio of the Cost of communications, computer etc. (% of service imports) in Morocco in 2010 to that in 2011?
Offer a very short reply. 1.05. What is the ratio of the Cost of communications, computer etc. (% of service imports) of United States in 2010 to that in 2011?
Your answer should be very brief. 0.95. What is the difference between the highest and the second highest Cost of communications, computer etc. (% of service imports) of East Asia (developing only)?
Provide a succinct answer. 0.57. What is the difference between the highest and the second highest Cost of communications, computer etc. (% of service imports) of Morocco?
Offer a terse response. 1.95. What is the difference between the highest and the second highest Cost of communications, computer etc. (% of service imports) of United States?
Make the answer very short. 1.68. What is the difference between the highest and the lowest Cost of communications, computer etc. (% of service imports) of East Asia (developing only)?
Provide a short and direct response. 7.14. What is the difference between the highest and the lowest Cost of communications, computer etc. (% of service imports) in Morocco?
Ensure brevity in your answer.  5.54. What is the difference between the highest and the lowest Cost of communications, computer etc. (% of service imports) of United States?
Offer a terse response. 9.72. 